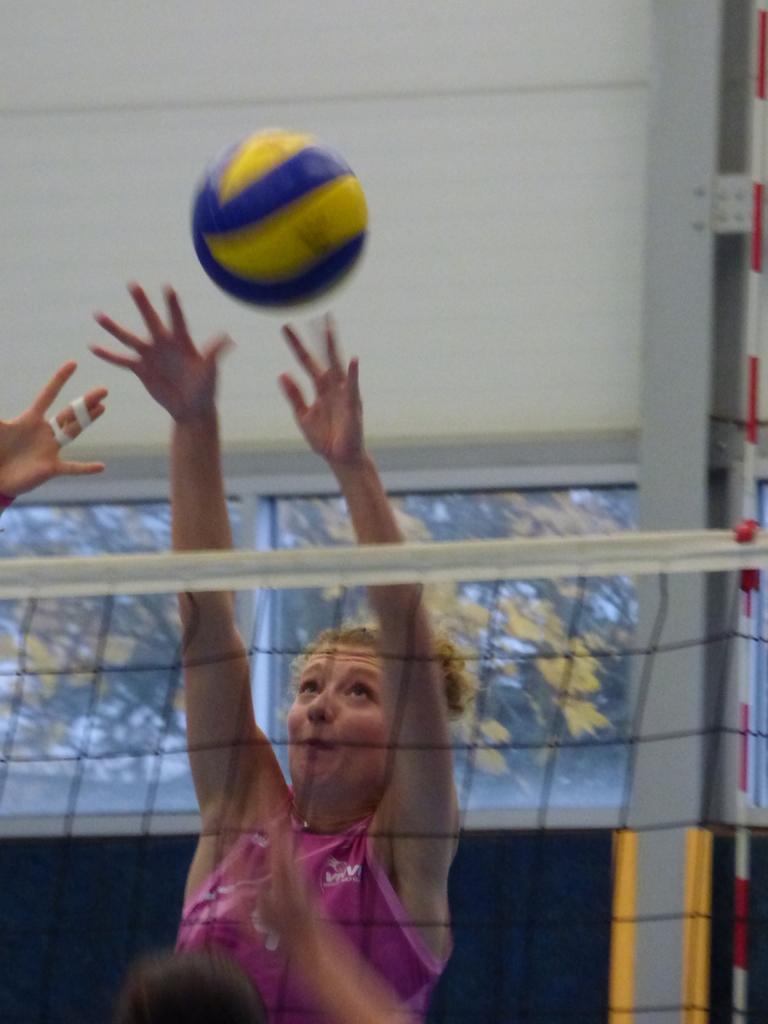Could you give a brief overview of what you see in this image? In this picture there is a girl wearing pink color t-shirt and playing the volleyball. In the front there is a fencing net. Behind there is a glass window and white color wall. 